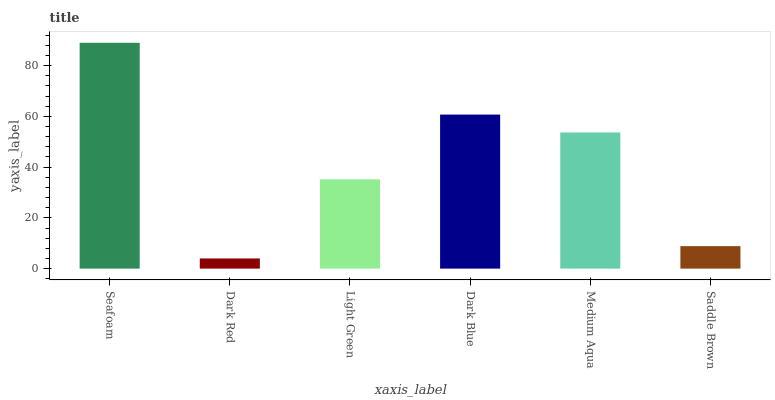Is Dark Red the minimum?
Answer yes or no. Yes. Is Seafoam the maximum?
Answer yes or no. Yes. Is Light Green the minimum?
Answer yes or no. No. Is Light Green the maximum?
Answer yes or no. No. Is Light Green greater than Dark Red?
Answer yes or no. Yes. Is Dark Red less than Light Green?
Answer yes or no. Yes. Is Dark Red greater than Light Green?
Answer yes or no. No. Is Light Green less than Dark Red?
Answer yes or no. No. Is Medium Aqua the high median?
Answer yes or no. Yes. Is Light Green the low median?
Answer yes or no. Yes. Is Dark Red the high median?
Answer yes or no. No. Is Medium Aqua the low median?
Answer yes or no. No. 